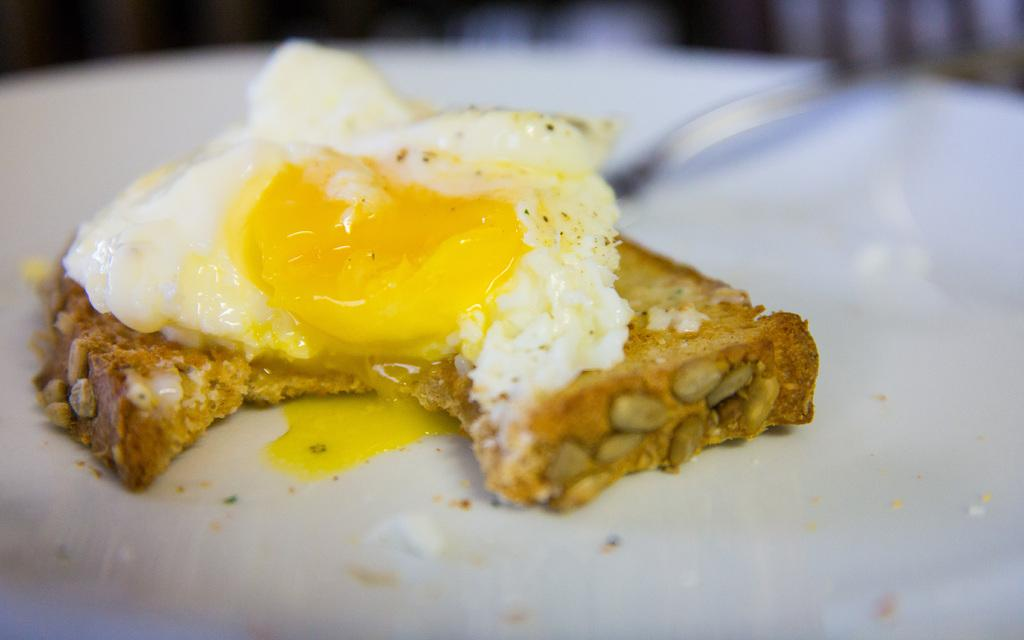What is present on the white surface in the image? There is food on a white surface in the image. Can you describe the background of the image? The background of the image is blurred. What type of argument is taking place in the image? There is no argument present in the image; it features food on a white surface with a blurred background. What type of vacation destination is depicted in the image? There is no vacation destination depicted in the image; it features food on a white surface with a blurred background. 